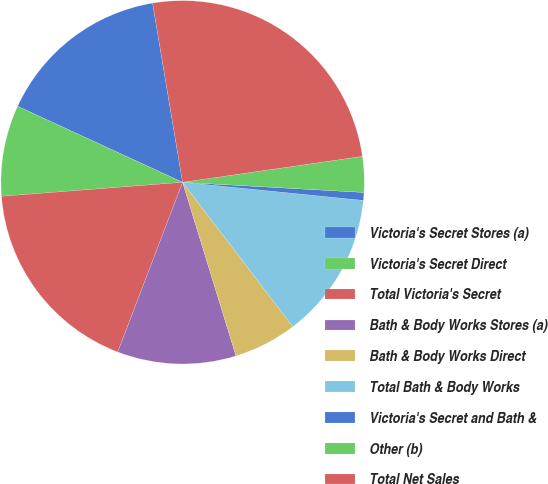Convert chart. <chart><loc_0><loc_0><loc_500><loc_500><pie_chart><fcel>Victoria's Secret Stores (a)<fcel>Victoria's Secret Direct<fcel>Total Victoria's Secret<fcel>Bath & Body Works Stores (a)<fcel>Bath & Body Works Direct<fcel>Total Bath & Body Works<fcel>Victoria's Secret and Bath &<fcel>Other (b)<fcel>Total Net Sales<nl><fcel>15.49%<fcel>8.1%<fcel>17.96%<fcel>10.56%<fcel>5.63%<fcel>13.03%<fcel>0.7%<fcel>3.17%<fcel>25.36%<nl></chart> 